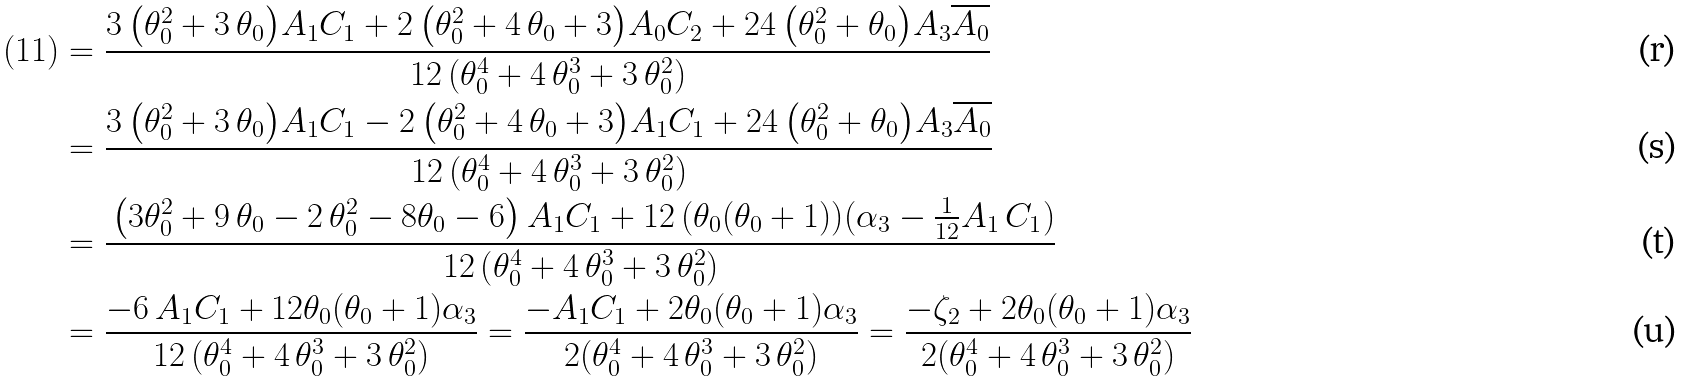Convert formula to latex. <formula><loc_0><loc_0><loc_500><loc_500>( 1 1 ) & = \frac { 3 \, { \left ( \theta _ { 0 } ^ { 2 } + 3 \, \theta _ { 0 } \right ) } A _ { 1 } C _ { 1 } + 2 \, { \left ( \theta _ { 0 } ^ { 2 } + 4 \, \theta _ { 0 } + 3 \right ) } A _ { 0 } C _ { 2 } + 2 4 \, { \left ( \theta _ { 0 } ^ { 2 } + \theta _ { 0 } \right ) } A _ { 3 } \overline { A _ { 0 } } } { 1 2 \, { \left ( \theta _ { 0 } ^ { 4 } + 4 \, \theta _ { 0 } ^ { 3 } + 3 \, \theta _ { 0 } ^ { 2 } \right ) } } \\ & = \frac { 3 \, { \left ( \theta _ { 0 } ^ { 2 } + 3 \, \theta _ { 0 } \right ) } A _ { 1 } C _ { 1 } - 2 \, { \left ( \theta _ { 0 } ^ { 2 } + 4 \, \theta _ { 0 } + 3 \right ) } A _ { 1 } C _ { 1 } + 2 4 \, { \left ( \theta _ { 0 } ^ { 2 } + \theta _ { 0 } \right ) } A _ { 3 } \overline { A _ { 0 } } } { 1 2 \, { \left ( \theta _ { 0 } ^ { 4 } + 4 \, \theta _ { 0 } ^ { 3 } + 3 \, \theta _ { 0 } ^ { 2 } \right ) } } \\ & = \frac { \, \left ( 3 \theta _ { 0 } ^ { 2 } + 9 \, \theta _ { 0 } - 2 \, \theta _ { 0 } ^ { 2 } - 8 \theta _ { 0 } - 6 \right ) A _ { 1 } C _ { 1 } + 1 2 \, { \left ( \theta _ { 0 } ( \theta _ { 0 } + 1 ) \right ) } ( \alpha _ { 3 } - \frac { 1 } { 1 2 } A _ { 1 } \, C _ { 1 } ) } { 1 2 \, { \left ( \theta _ { 0 } ^ { 4 } + 4 \, \theta _ { 0 } ^ { 3 } + 3 \, \theta _ { 0 } ^ { 2 } \right ) } } \\ & = \frac { - 6 \, A _ { 1 } C _ { 1 } + 1 2 \theta _ { 0 } ( \theta _ { 0 } + 1 ) \alpha _ { 3 } } { 1 2 \, { \left ( \theta _ { 0 } ^ { 4 } + 4 \, \theta _ { 0 } ^ { 3 } + 3 \, \theta _ { 0 } ^ { 2 } \right ) } } = \frac { - A _ { 1 } C _ { 1 } + 2 \theta _ { 0 } ( \theta _ { 0 } + 1 ) \alpha _ { 3 } } { 2 { \left ( \theta _ { 0 } ^ { 4 } + 4 \, \theta _ { 0 } ^ { 3 } + 3 \, \theta _ { 0 } ^ { 2 } \right ) } } = \frac { - \zeta _ { 2 } + 2 \theta _ { 0 } ( \theta _ { 0 } + 1 ) \alpha _ { 3 } } { 2 { \left ( \theta _ { 0 } ^ { 4 } + 4 \, \theta _ { 0 } ^ { 3 } + 3 \, \theta _ { 0 } ^ { 2 } \right ) } }</formula> 